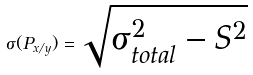<formula> <loc_0><loc_0><loc_500><loc_500>\sigma ( P _ { x / y } ) = \sqrt { \sigma _ { t o t a l } ^ { 2 } - S ^ { 2 } }</formula> 